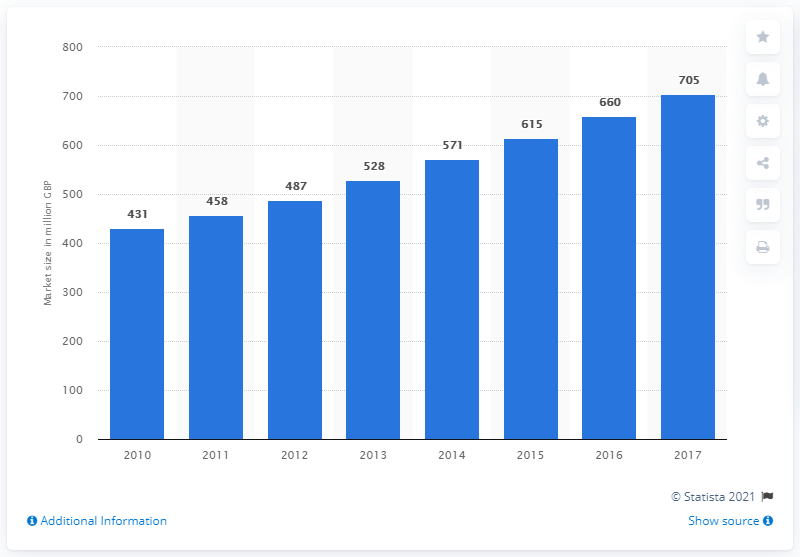Point out several critical features in this image. The cyber security sector in the UK began to grow in the year 2010. The estimated size of the global cybersecurity market in 2017 was approximately 705 billion US dollars. 